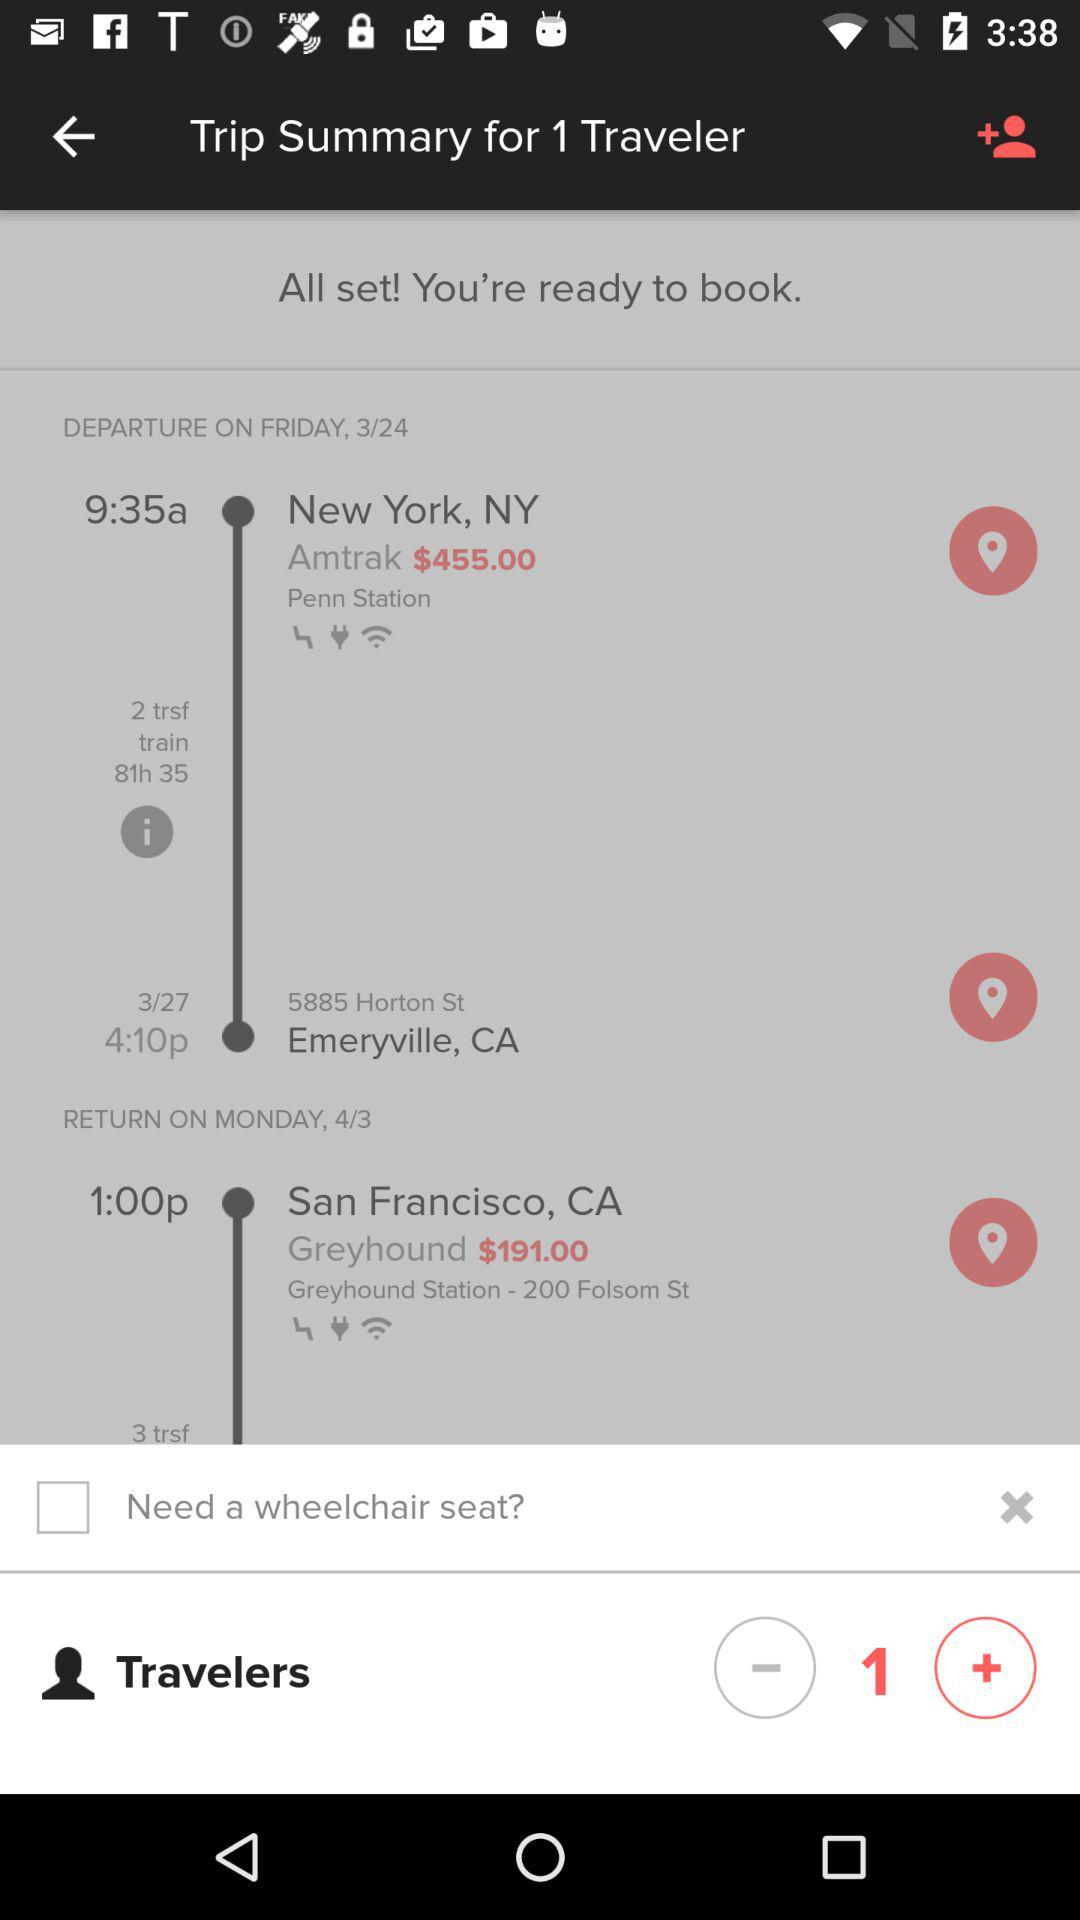What's the destination? The destination is Emeryville, CA. 